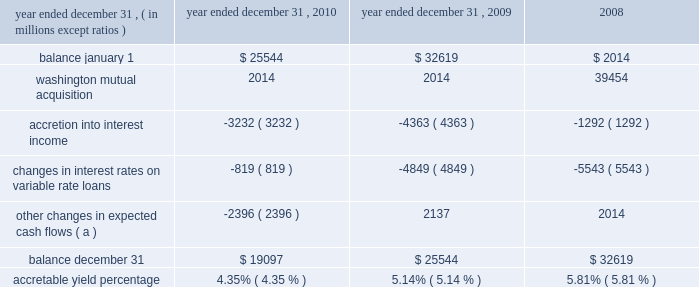Notes to consolidated financial statements 236 jpmorgan chase & co./2010 annual report the table below sets forth the accretable yield activity for the firm 2019s pci consumer loans for the years ended december 31 , 2010 , 2009 and .
( a ) other changes in expected cash flows may vary from period to period as the firm continues to refine its cash flow model and periodically updates model assumptions .
For the years ended december 31 , 2010 and 2009 , other changes in expected cash flows were principally driven by changes in prepayment assumptions , as well as reclassification to the nonaccretable difference .
Such changes are expected to have an insignificant impact on the accretable yield percentage .
The factors that most significantly affect estimates of gross cash flows expected to be collected , and accordingly the accretable yield balance , include : ( i ) changes in the benchmark interest rate indices for variable rate products such as option arm and home equity loans ; and ( ii ) changes in prepayment assump- tions .
To date , the decrease in the accretable yield percentage has been primarily related to a decrease in interest rates on vari- able-rate loans and , to a lesser extent , extended loan liquida- tion periods .
Certain events , such as extended loan liquidation periods , affect the timing of expected cash flows but not the amount of cash expected to be received ( i.e. , the accretable yield balance ) .
Extended loan liquidation periods reduce the accretable yield percentage because the same accretable yield balance is recognized against a higher-than-expected loan balance over a longer-than-expected period of time. .
What was the average balance of total pci consumer loans for the years ended december 31 , 2010 and 2009? 
Computations: ((19097 + 25544) / 2)
Answer: 22320.5. 